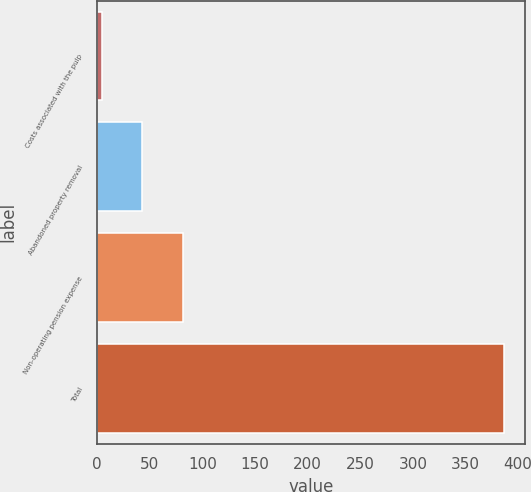Convert chart to OTSL. <chart><loc_0><loc_0><loc_500><loc_500><bar_chart><fcel>Costs associated with the pulp<fcel>Abandoned property removal<fcel>Non-operating pension expense<fcel>Total<nl><fcel>5<fcel>43.2<fcel>81.4<fcel>387<nl></chart> 